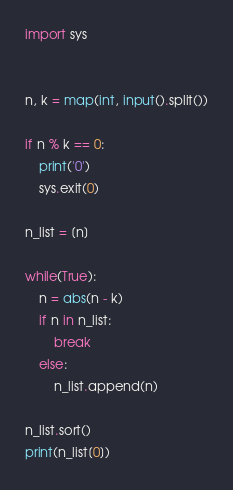<code> <loc_0><loc_0><loc_500><loc_500><_Python_>import sys


n, k = map(int, input().split())

if n % k == 0:
    print('0')
    sys.exit(0)

n_list = [n]

while(True):
    n = abs(n - k)
    if n in n_list:
        break
    else:
        n_list.append(n)

n_list.sort()
print(n_list[0])</code> 